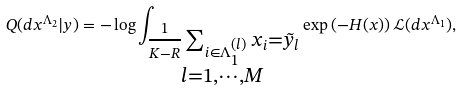<formula> <loc_0><loc_0><loc_500><loc_500>Q ( d x ^ { \Lambda _ { 2 } } | y ) = - \log \int _ { \substack { \frac { 1 } { K - R } \sum _ { i \in \Lambda _ { 1 } ^ { ( l ) } } x _ { i } = \tilde { y } _ { l } \\ l = 1 , \cdots , M } } \exp \left ( - H ( x ) \right ) \mathcal { L } ( d x ^ { \Lambda _ { 1 } } ) ,</formula> 